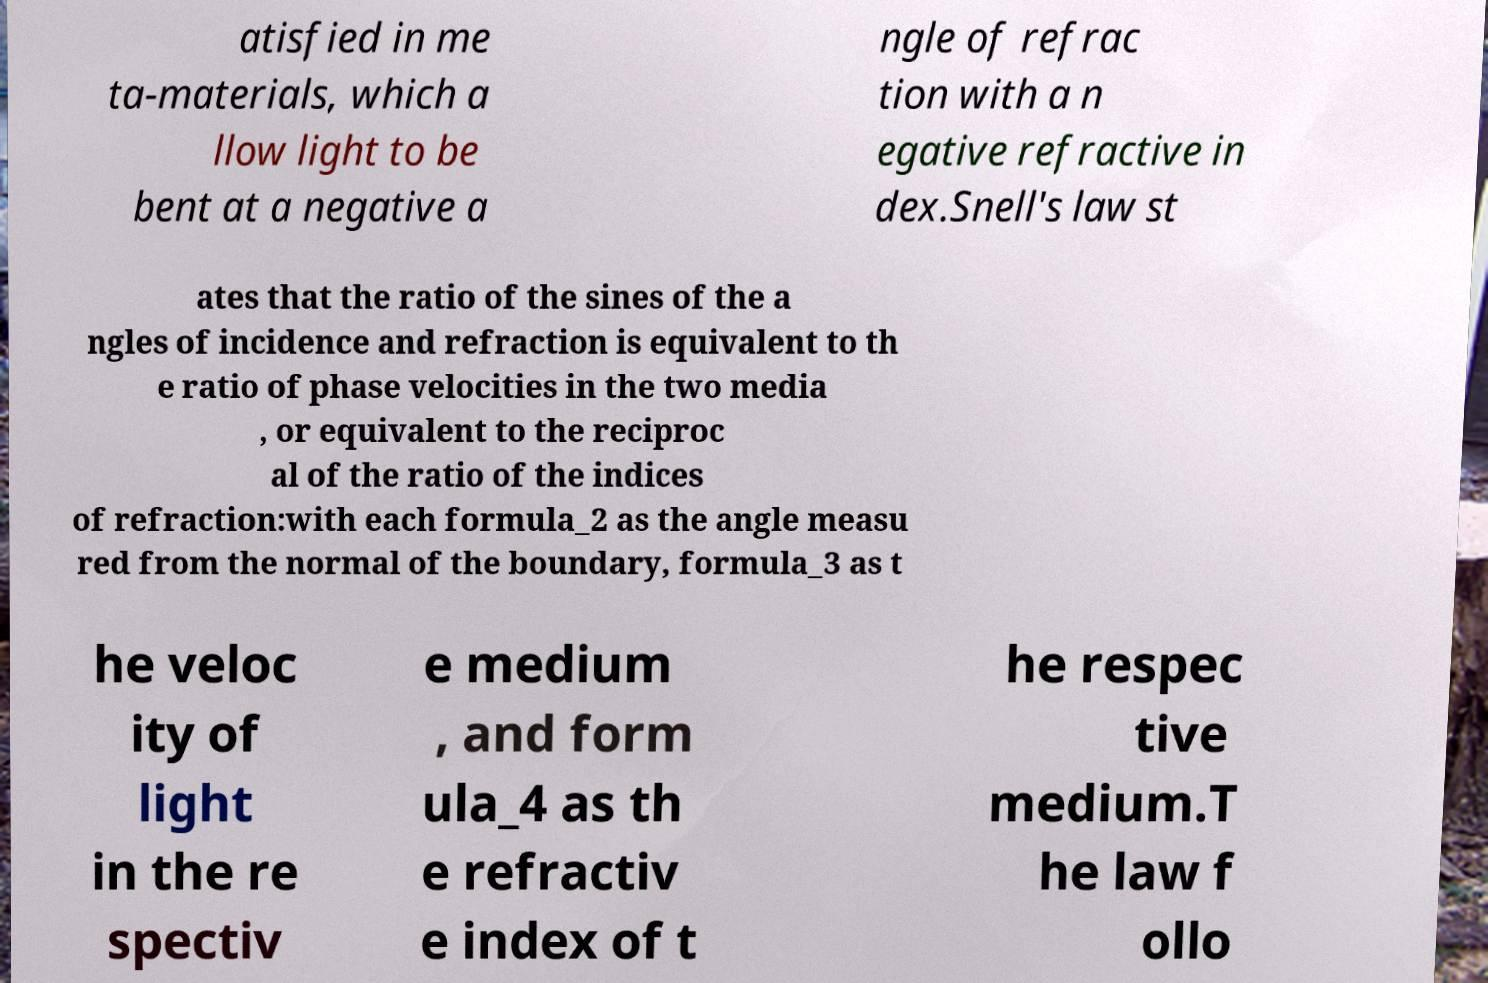Please identify and transcribe the text found in this image. atisfied in me ta-materials, which a llow light to be bent at a negative a ngle of refrac tion with a n egative refractive in dex.Snell's law st ates that the ratio of the sines of the a ngles of incidence and refraction is equivalent to th e ratio of phase velocities in the two media , or equivalent to the reciproc al of the ratio of the indices of refraction:with each formula_2 as the angle measu red from the normal of the boundary, formula_3 as t he veloc ity of light in the re spectiv e medium , and form ula_4 as th e refractiv e index of t he respec tive medium.T he law f ollo 